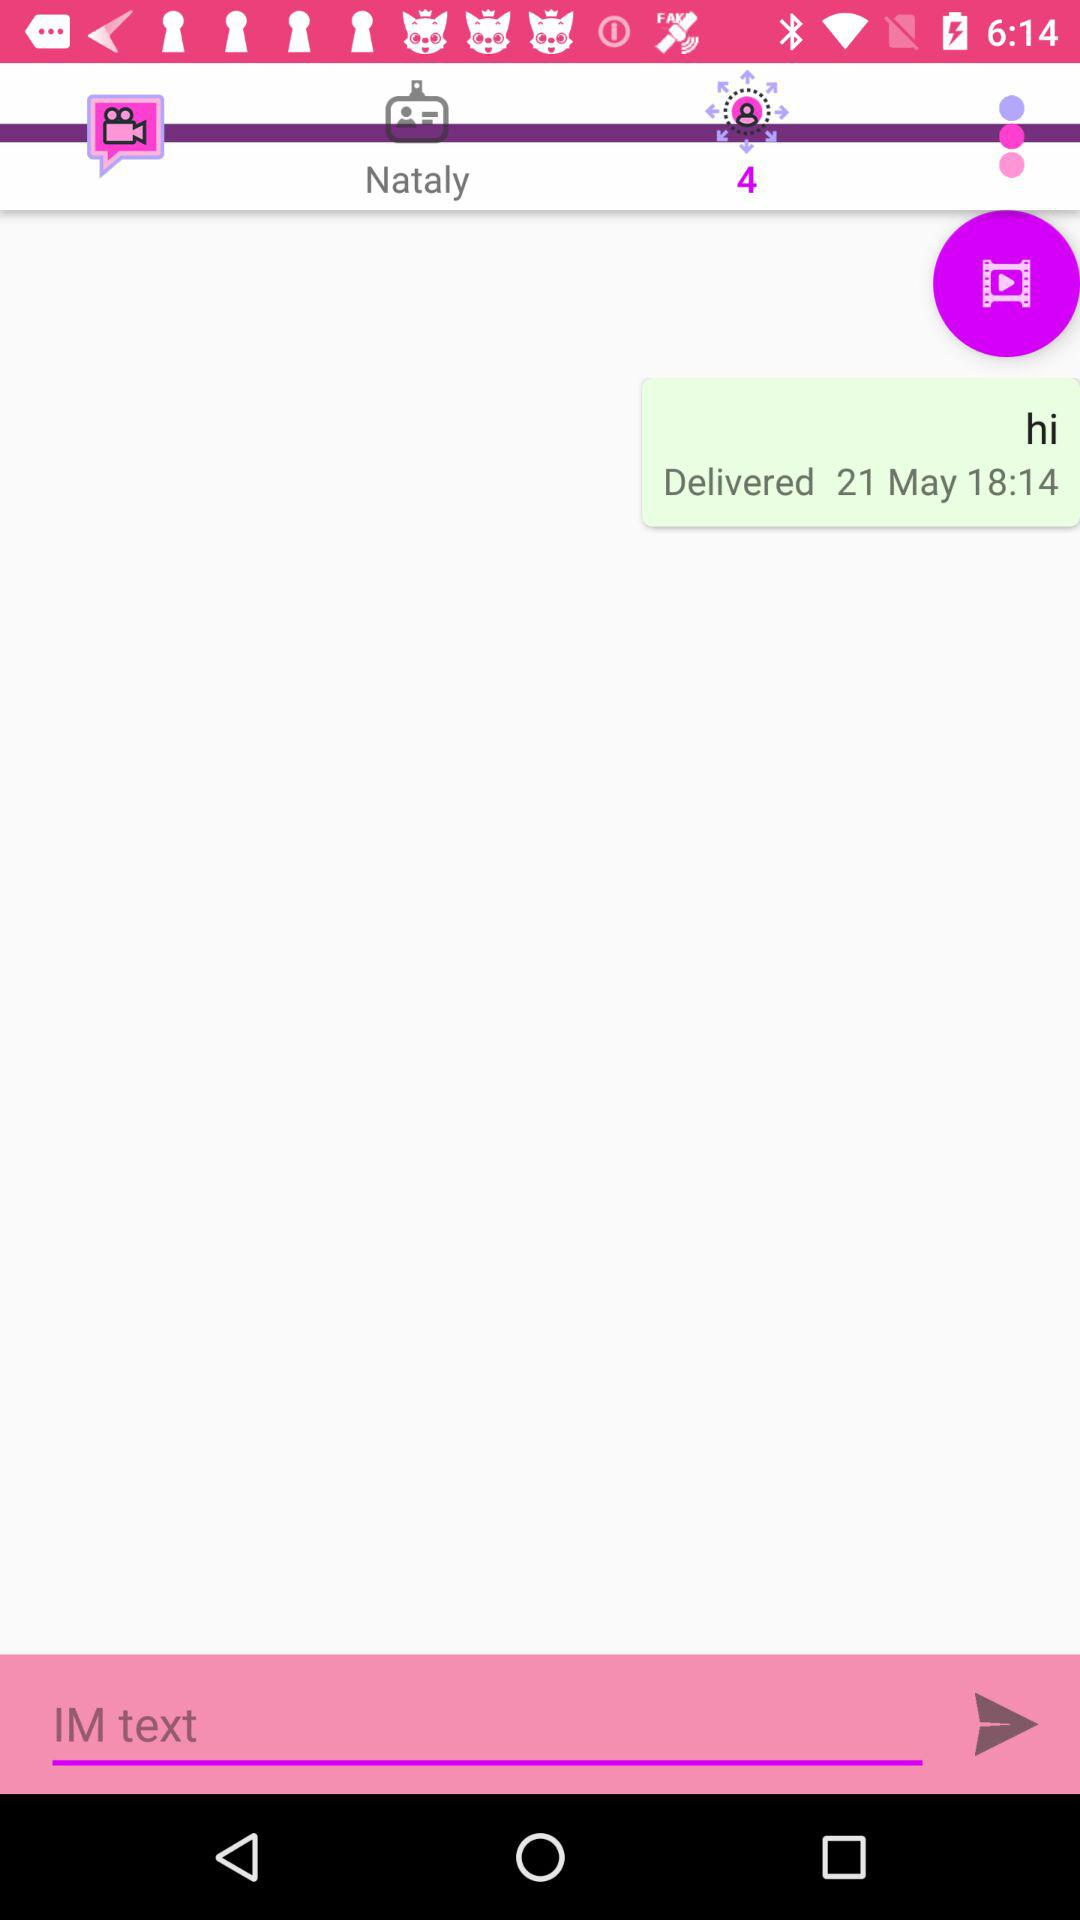At what time was the message 'hi' delivered? It was delivered at 18:14. 